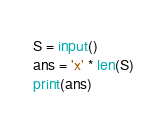Convert code to text. <code><loc_0><loc_0><loc_500><loc_500><_Python_>S = input()
ans = 'x' * len(S)
print(ans)</code> 